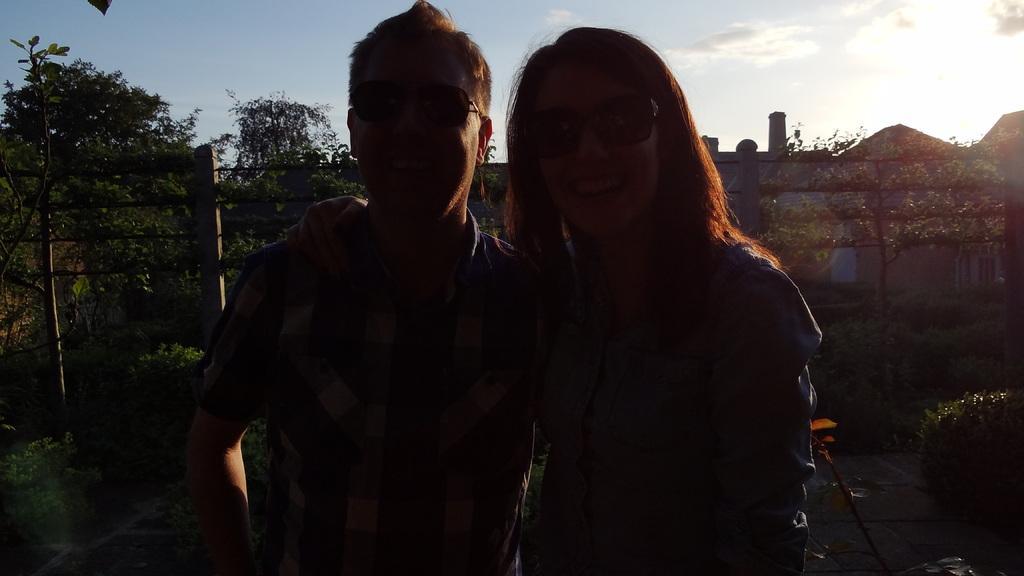Please provide a concise description of this image. There is a man and a woman in the foreground area of the image, there are plants, a boundary and the sky in the sky. 